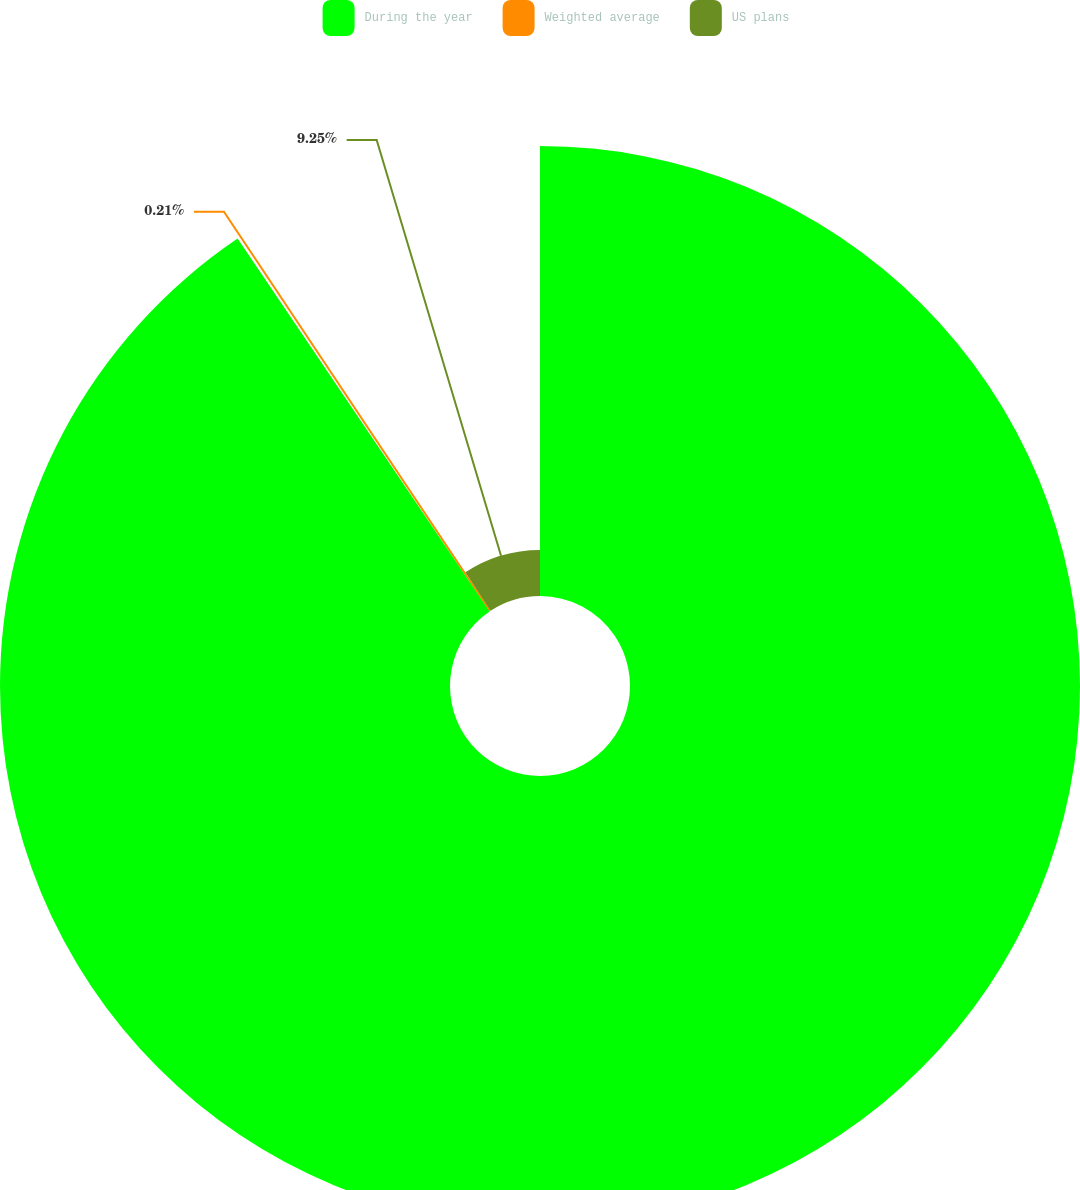Convert chart to OTSL. <chart><loc_0><loc_0><loc_500><loc_500><pie_chart><fcel>During the year<fcel>Weighted average<fcel>US plans<nl><fcel>90.54%<fcel>0.21%<fcel>9.25%<nl></chart> 